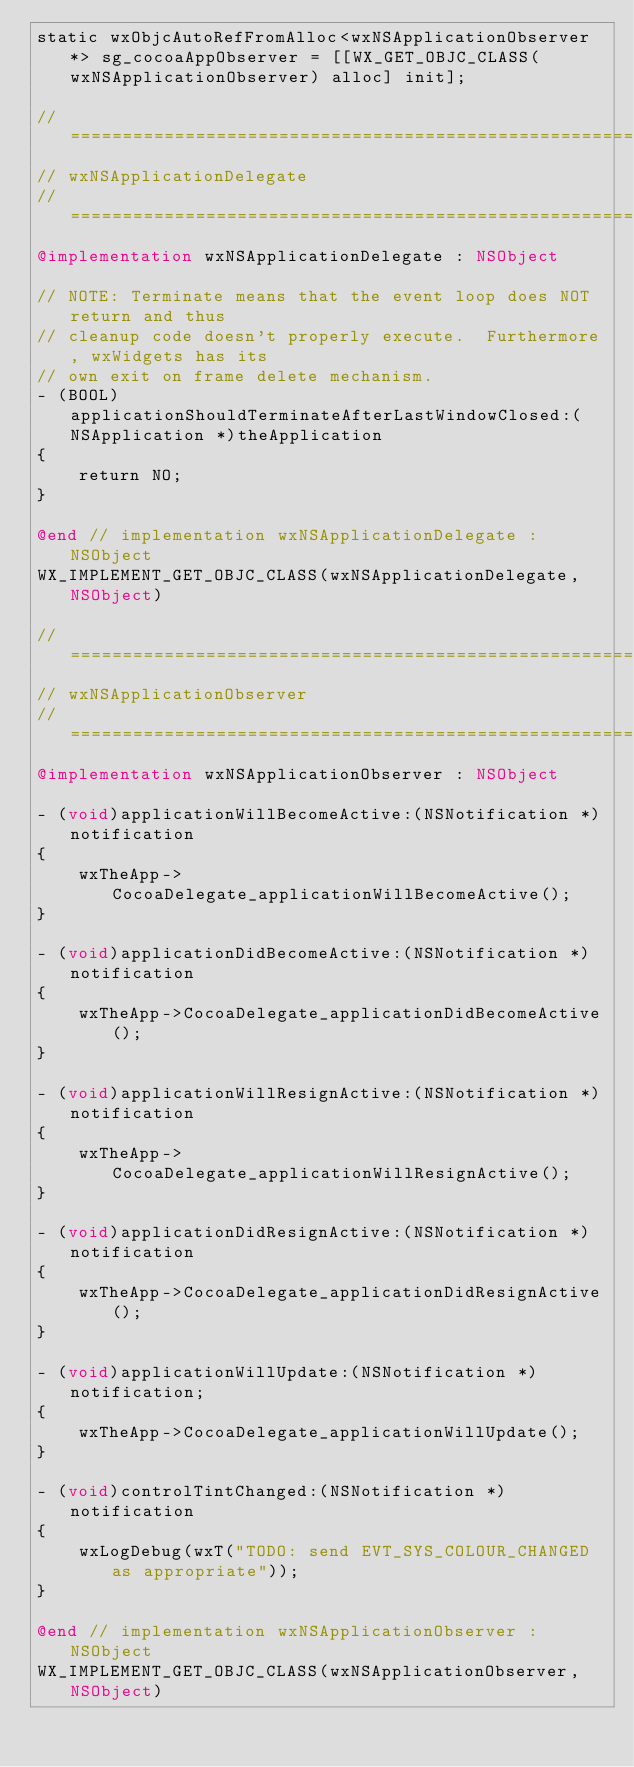Convert code to text. <code><loc_0><loc_0><loc_500><loc_500><_ObjectiveC_>static wxObjcAutoRefFromAlloc<wxNSApplicationObserver*> sg_cocoaAppObserver = [[WX_GET_OBJC_CLASS(wxNSApplicationObserver) alloc] init];

// ========================================================================
// wxNSApplicationDelegate
// ========================================================================
@implementation wxNSApplicationDelegate : NSObject

// NOTE: Terminate means that the event loop does NOT return and thus
// cleanup code doesn't properly execute.  Furthermore, wxWidgets has its
// own exit on frame delete mechanism.
- (BOOL)applicationShouldTerminateAfterLastWindowClosed:(NSApplication *)theApplication
{
    return NO;
}

@end // implementation wxNSApplicationDelegate : NSObject
WX_IMPLEMENT_GET_OBJC_CLASS(wxNSApplicationDelegate,NSObject)

// ========================================================================
// wxNSApplicationObserver
// ========================================================================
@implementation wxNSApplicationObserver : NSObject

- (void)applicationWillBecomeActive:(NSNotification *)notification
{
    wxTheApp->CocoaDelegate_applicationWillBecomeActive();
}

- (void)applicationDidBecomeActive:(NSNotification *)notification
{
    wxTheApp->CocoaDelegate_applicationDidBecomeActive();
}

- (void)applicationWillResignActive:(NSNotification *)notification
{
    wxTheApp->CocoaDelegate_applicationWillResignActive();
}

- (void)applicationDidResignActive:(NSNotification *)notification
{
    wxTheApp->CocoaDelegate_applicationDidResignActive();
}

- (void)applicationWillUpdate:(NSNotification *)notification;
{
    wxTheApp->CocoaDelegate_applicationWillUpdate();
}

- (void)controlTintChanged:(NSNotification *)notification
{
    wxLogDebug(wxT("TODO: send EVT_SYS_COLOUR_CHANGED as appropriate"));
}

@end // implementation wxNSApplicationObserver : NSObject
WX_IMPLEMENT_GET_OBJC_CLASS(wxNSApplicationObserver,NSObject)
</code> 